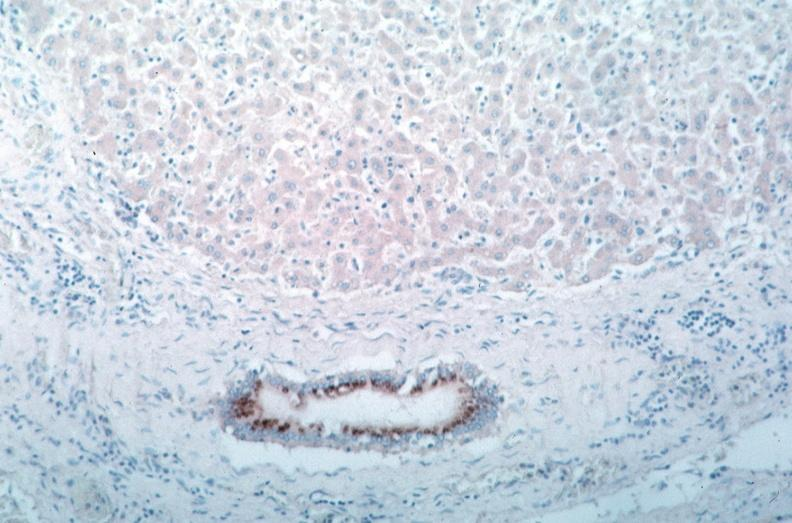s lateral view spotted fever, immunoperoxidase staining vessels for rickettsia rickettsii?
Answer the question using a single word or phrase. No 